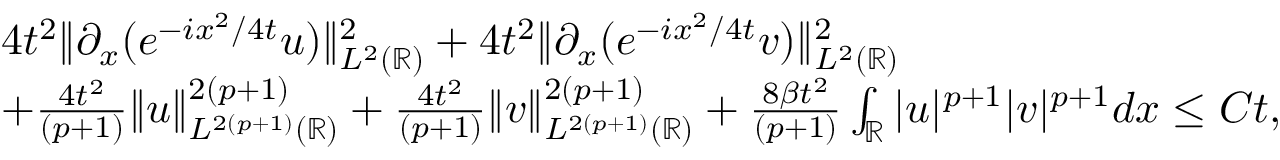Convert formula to latex. <formula><loc_0><loc_0><loc_500><loc_500>\begin{array} { r l } & { 4 t ^ { 2 } \| \partial _ { x } ( e ^ { - i x ^ { 2 } / 4 t } u ) \| _ { L ^ { 2 } ( \mathbb { R } ) } ^ { 2 } + 4 t ^ { 2 } \| \partial _ { x } ( e ^ { - i x ^ { 2 } / 4 t } v ) \| _ { L ^ { 2 } ( \mathbb { R } ) } ^ { 2 } } \\ & { + \frac { 4 t ^ { 2 } } { ( p + 1 ) } \| u \| _ { L ^ { 2 ( p + 1 ) } ( \mathbb { R } ) } ^ { 2 ( p + 1 ) } + \frac { 4 t ^ { 2 } } { ( p + 1 ) } \| v \| _ { L ^ { 2 ( p + 1 ) } ( \mathbb { R } ) } ^ { 2 ( p + 1 ) } + \frac { 8 \beta t ^ { 2 } } { ( p + 1 ) } \int _ { \mathbb { R } } | u | ^ { p + 1 } | v | ^ { p + 1 } d x \leq C t , } \end{array}</formula> 